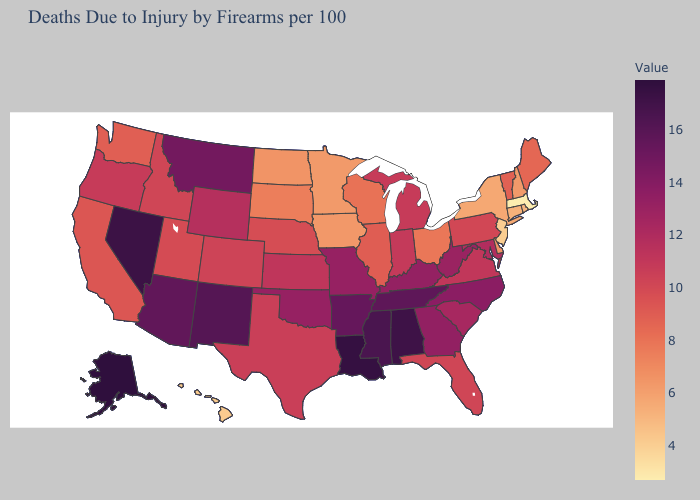Is the legend a continuous bar?
Answer briefly. Yes. Which states have the lowest value in the Northeast?
Give a very brief answer. Massachusetts. Does Virginia have the highest value in the USA?
Write a very short answer. No. 